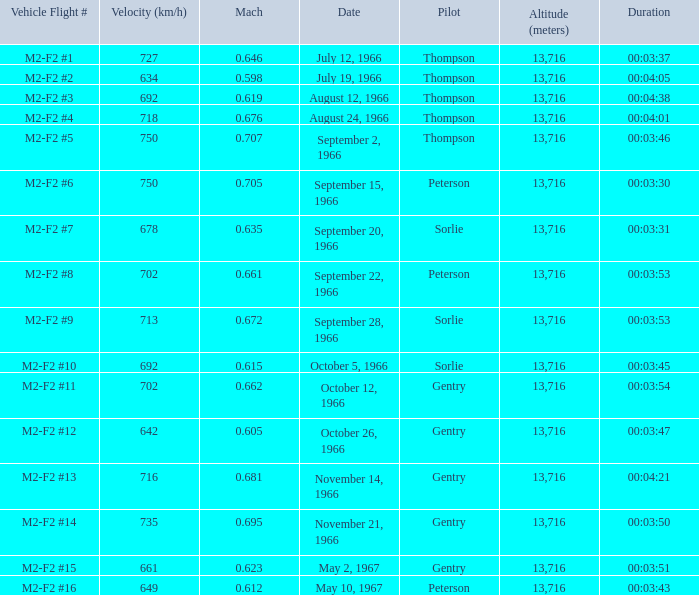What Vehicle Flight # has Pilot Peterson and Velocity (km/h) of 649? M2-F2 #16. Parse the table in full. {'header': ['Vehicle Flight #', 'Velocity (km/h)', 'Mach', 'Date', 'Pilot', 'Altitude (meters)', 'Duration'], 'rows': [['M2-F2 #1', '727', '0.646', 'July 12, 1966', 'Thompson', '13,716', '00:03:37'], ['M2-F2 #2', '634', '0.598', 'July 19, 1966', 'Thompson', '13,716', '00:04:05'], ['M2-F2 #3', '692', '0.619', 'August 12, 1966', 'Thompson', '13,716', '00:04:38'], ['M2-F2 #4', '718', '0.676', 'August 24, 1966', 'Thompson', '13,716', '00:04:01'], ['M2-F2 #5', '750', '0.707', 'September 2, 1966', 'Thompson', '13,716', '00:03:46'], ['M2-F2 #6', '750', '0.705', 'September 15, 1966', 'Peterson', '13,716', '00:03:30'], ['M2-F2 #7', '678', '0.635', 'September 20, 1966', 'Sorlie', '13,716', '00:03:31'], ['M2-F2 #8', '702', '0.661', 'September 22, 1966', 'Peterson', '13,716', '00:03:53'], ['M2-F2 #9', '713', '0.672', 'September 28, 1966', 'Sorlie', '13,716', '00:03:53'], ['M2-F2 #10', '692', '0.615', 'October 5, 1966', 'Sorlie', '13,716', '00:03:45'], ['M2-F2 #11', '702', '0.662', 'October 12, 1966', 'Gentry', '13,716', '00:03:54'], ['M2-F2 #12', '642', '0.605', 'October 26, 1966', 'Gentry', '13,716', '00:03:47'], ['M2-F2 #13', '716', '0.681', 'November 14, 1966', 'Gentry', '13,716', '00:04:21'], ['M2-F2 #14', '735', '0.695', 'November 21, 1966', 'Gentry', '13,716', '00:03:50'], ['M2-F2 #15', '661', '0.623', 'May 2, 1967', 'Gentry', '13,716', '00:03:51'], ['M2-F2 #16', '649', '0.612', 'May 10, 1967', 'Peterson', '13,716', '00:03:43']]} 